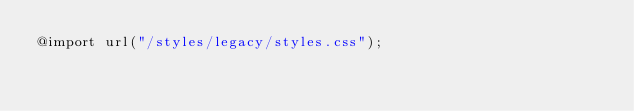<code> <loc_0><loc_0><loc_500><loc_500><_CSS_>@import url("/styles/legacy/styles.css");</code> 